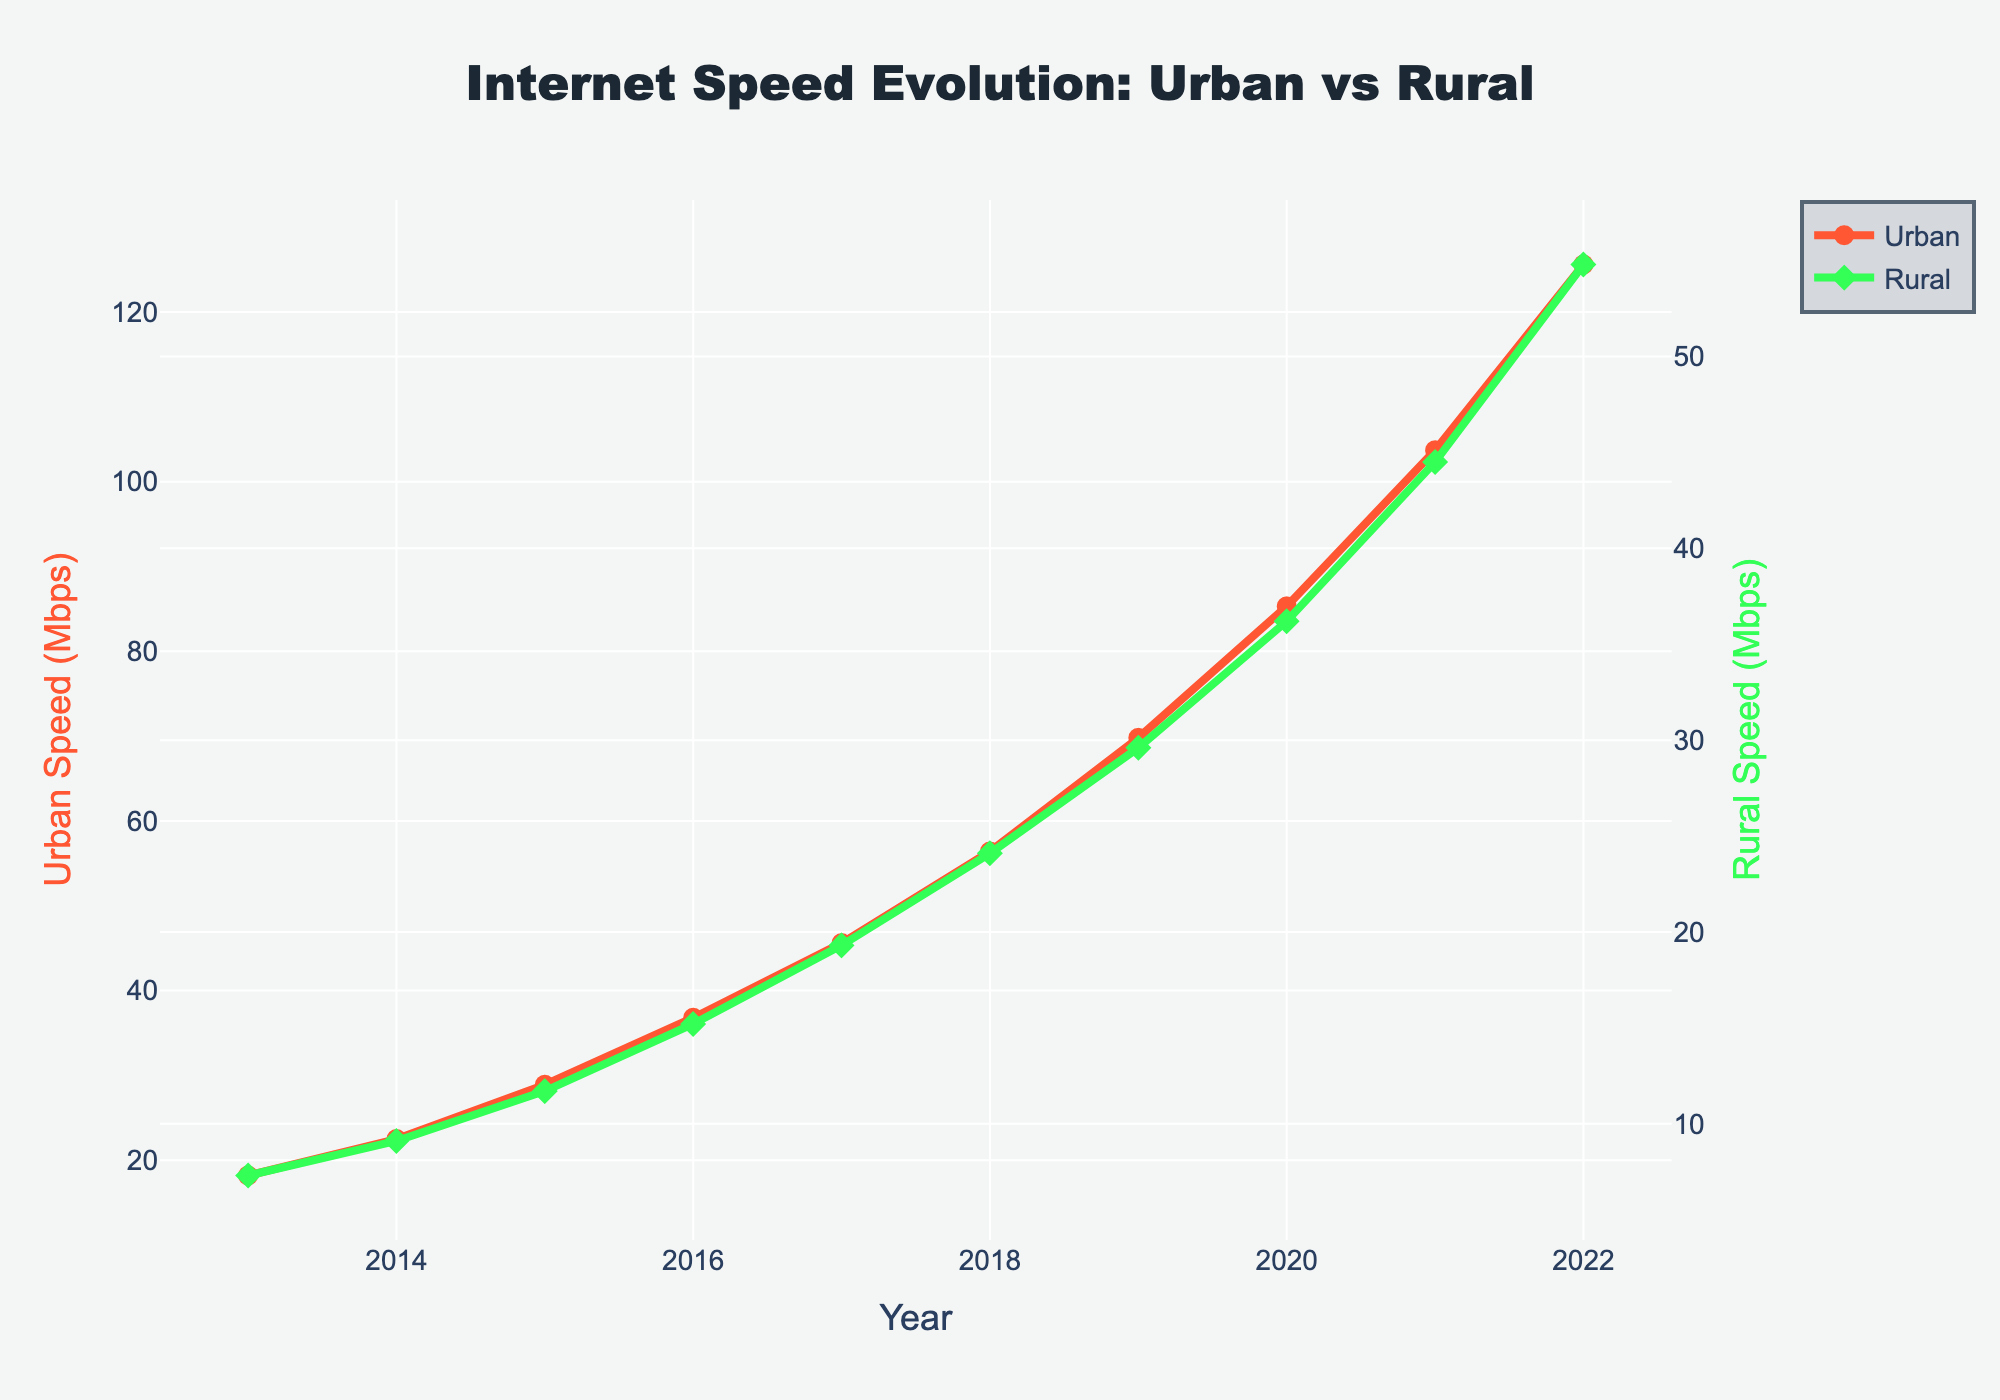What's the urban Internet speed in 2015? Look at the value of the line corresponding to the urban area in 2015.
Answer: 28.9 Mbps How much did the rural Internet speed increase from 2018 to 2022? Subtract the rural Internet speed value in 2018 from the value in 2022. 54.8 - 24.1 = 30.7 Mbps
Answer: 30.7 Mbps By how many Mbps did the urban Internet speed exceed the rural Internet speed in 2022? Subtract the rural Internet speed in 2022 from the urban Internet speed in 2022. 125.6 - 54.8 = 70.8 Mbps
Answer: 70.8 Mbps Which had a higher speed increase from 2013 to 2020, urban or rural areas? Calculate the speed increase for both areas and compare. Urban: 85.3 - 18.2 = 67.1 Mbps; Rural: 36.2 - 7.3 = 28.9 Mbps
Answer: Urban areas Identify the year when the urban Internet speed first crossed 50 Mbps. Check the urban line and identify the year when the speed exceeds 50 Mbps for the first time.
Answer: 2018 Compare the Internet speed growth rate between 2015 and 2017 for urban and rural areas. Which grew faster? Calculate the yearly growth rate for both areas in the specified period. Urban: (45.6 - 28.9)/2 = 8.35 Mbps/year; Rural: (19.3 - 11.7)/2 = 3.8 Mbps/year
Answer: Urban areas What are the visual markers used for urban and rural areas on the graph? Observe the shape and style of the markers used in the plot.
Answer: Circle for urban, diamond for rural 